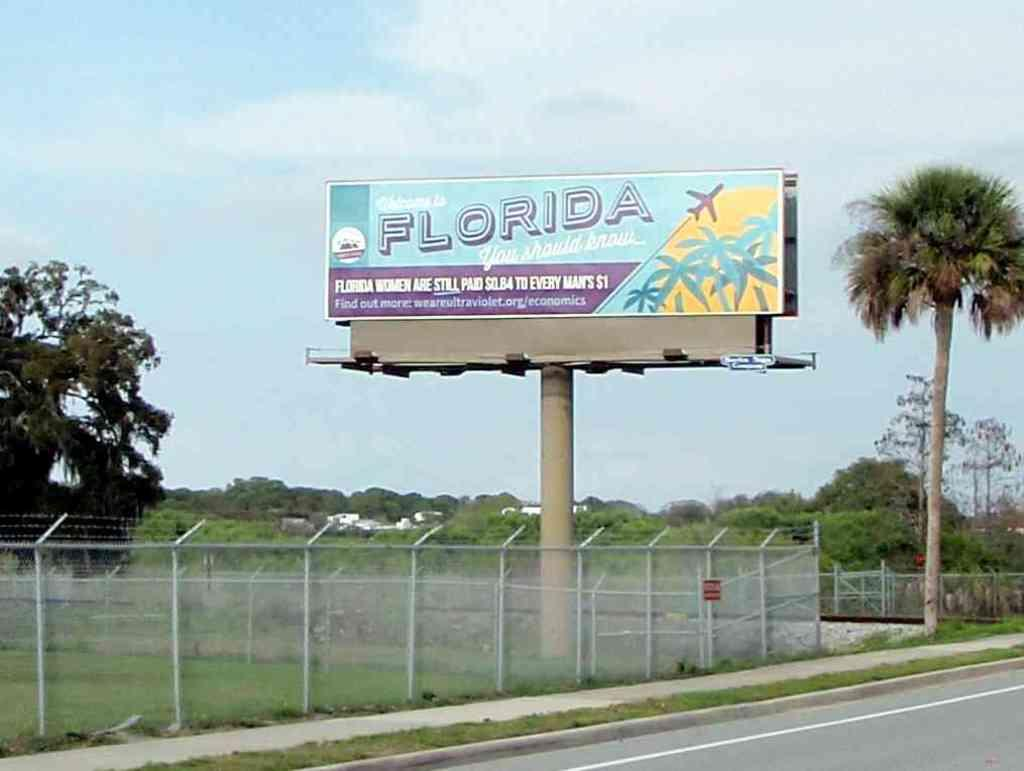Provide a one-sentence caption for the provided image. A Florida billboard bemoans women's lack of equal pay compared to men. 